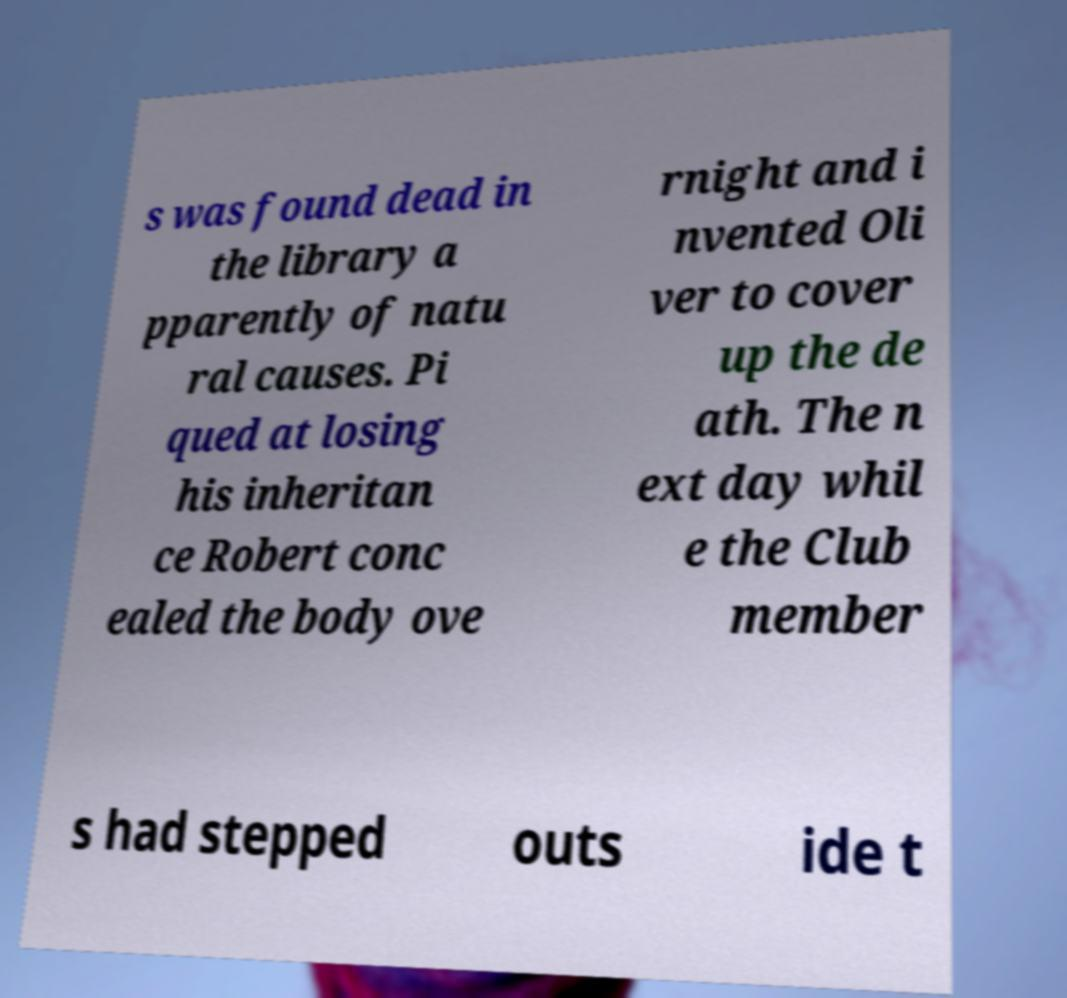For documentation purposes, I need the text within this image transcribed. Could you provide that? s was found dead in the library a pparently of natu ral causes. Pi qued at losing his inheritan ce Robert conc ealed the body ove rnight and i nvented Oli ver to cover up the de ath. The n ext day whil e the Club member s had stepped outs ide t 